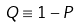Convert formula to latex. <formula><loc_0><loc_0><loc_500><loc_500>Q \equiv 1 - P</formula> 